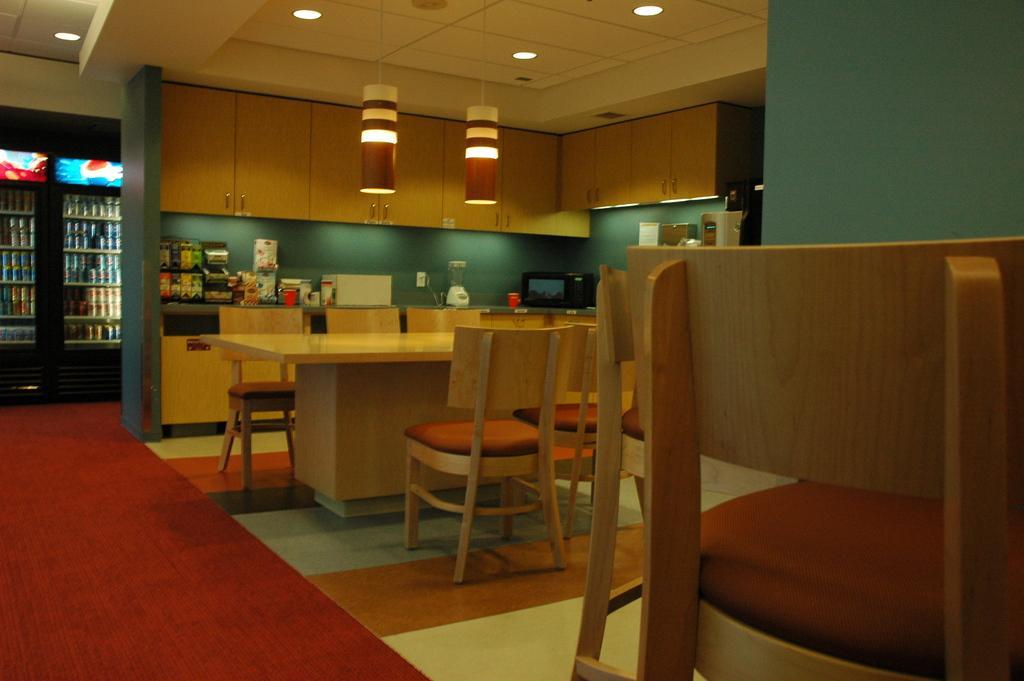Could you give a brief overview of what you see in this image? This is a picture of a kitchen. In this picture there are chairs, table, microwave oven, lights closet, mat and many other kitchen utensils. On the left there is a refrigerator, in the refrigerator there are drinks and other food items. 